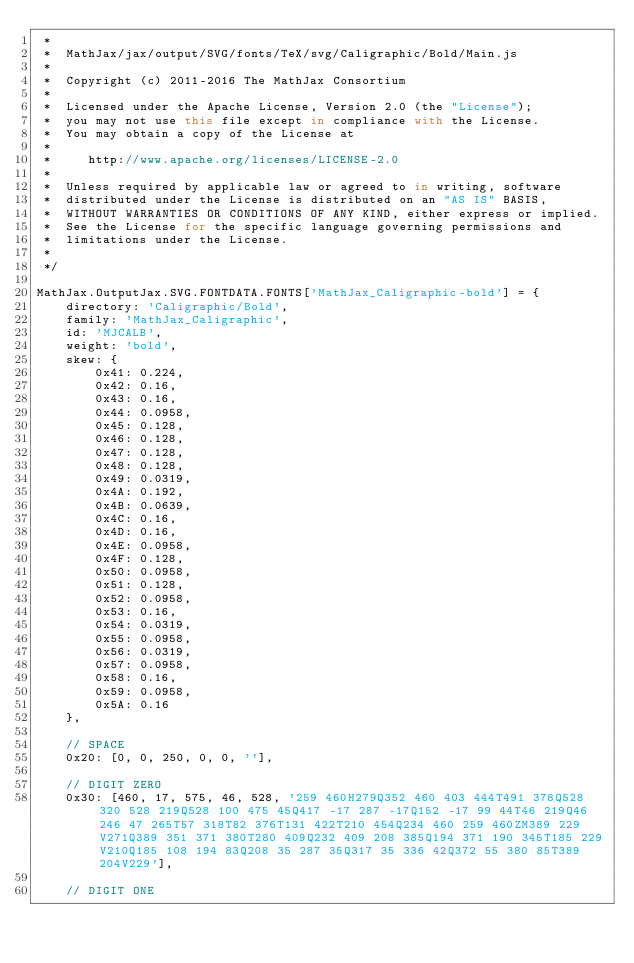<code> <loc_0><loc_0><loc_500><loc_500><_JavaScript_> *
 *  MathJax/jax/output/SVG/fonts/TeX/svg/Caligraphic/Bold/Main.js
 *
 *  Copyright (c) 2011-2016 The MathJax Consortium
 *
 *  Licensed under the Apache License, Version 2.0 (the "License");
 *  you may not use this file except in compliance with the License.
 *  You may obtain a copy of the License at
 *
 *     http://www.apache.org/licenses/LICENSE-2.0
 *
 *  Unless required by applicable law or agreed to in writing, software
 *  distributed under the License is distributed on an "AS IS" BASIS,
 *  WITHOUT WARRANTIES OR CONDITIONS OF ANY KIND, either express or implied.
 *  See the License for the specific language governing permissions and
 *  limitations under the License.
 *
 */

MathJax.OutputJax.SVG.FONTDATA.FONTS['MathJax_Caligraphic-bold'] = {
    directory: 'Caligraphic/Bold',
    family: 'MathJax_Caligraphic',
    id: 'MJCALB',
    weight: 'bold',
    skew: {
        0x41: 0.224,
        0x42: 0.16,
        0x43: 0.16,
        0x44: 0.0958,
        0x45: 0.128,
        0x46: 0.128,
        0x47: 0.128,
        0x48: 0.128,
        0x49: 0.0319,
        0x4A: 0.192,
        0x4B: 0.0639,
        0x4C: 0.16,
        0x4D: 0.16,
        0x4E: 0.0958,
        0x4F: 0.128,
        0x50: 0.0958,
        0x51: 0.128,
        0x52: 0.0958,
        0x53: 0.16,
        0x54: 0.0319,
        0x55: 0.0958,
        0x56: 0.0319,
        0x57: 0.0958,
        0x58: 0.16,
        0x59: 0.0958,
        0x5A: 0.16
    },

    // SPACE
    0x20: [0, 0, 250, 0, 0, ''],

    // DIGIT ZERO
    0x30: [460, 17, 575, 46, 528, '259 460H279Q352 460 403 444T491 378Q528 320 528 219Q528 100 475 45Q417 -17 287 -17Q152 -17 99 44T46 219Q46 246 47 265T57 318T82 376T131 422T210 454Q234 460 259 460ZM389 229V271Q389 351 371 380T280 409Q232 409 208 385Q194 371 190 345T185 229V210Q185 108 194 83Q208 35 287 35Q317 35 336 42Q372 55 380 85T389 204V229'],

    // DIGIT ONE</code> 